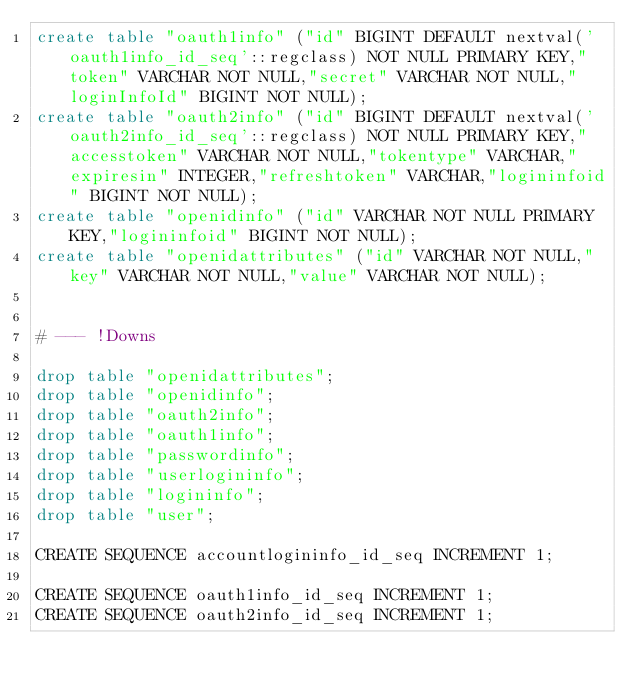Convert code to text. <code><loc_0><loc_0><loc_500><loc_500><_SQL_>create table "oauth1info" ("id" BIGINT DEFAULT nextval('oauth1info_id_seq'::regclass) NOT NULL PRIMARY KEY,"token" VARCHAR NOT NULL,"secret" VARCHAR NOT NULL,"loginInfoId" BIGINT NOT NULL);
create table "oauth2info" ("id" BIGINT DEFAULT nextval('oauth2info_id_seq'::regclass) NOT NULL PRIMARY KEY,"accesstoken" VARCHAR NOT NULL,"tokentype" VARCHAR,"expiresin" INTEGER,"refreshtoken" VARCHAR,"logininfoid" BIGINT NOT NULL);
create table "openidinfo" ("id" VARCHAR NOT NULL PRIMARY KEY,"logininfoid" BIGINT NOT NULL);
create table "openidattributes" ("id" VARCHAR NOT NULL,"key" VARCHAR NOT NULL,"value" VARCHAR NOT NULL);


# --- !Downs

drop table "openidattributes";
drop table "openidinfo";
drop table "oauth2info";
drop table "oauth1info";
drop table "passwordinfo";
drop table "userlogininfo";
drop table "logininfo";
drop table "user";

CREATE SEQUENCE accountlogininfo_id_seq INCREMENT 1;

CREATE SEQUENCE oauth1info_id_seq INCREMENT 1;
CREATE SEQUENCE oauth2info_id_seq INCREMENT 1;

</code> 